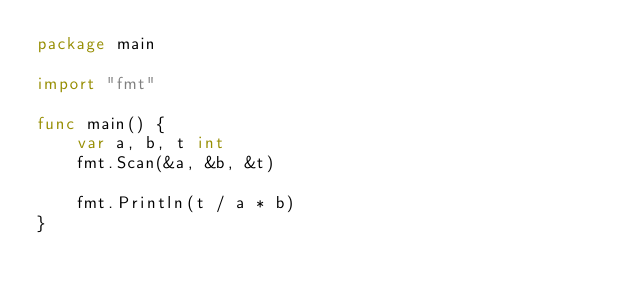<code> <loc_0><loc_0><loc_500><loc_500><_Go_>package main

import "fmt"

func main() {
	var a, b, t int
	fmt.Scan(&a, &b, &t)

	fmt.Println(t / a * b)
}
</code> 